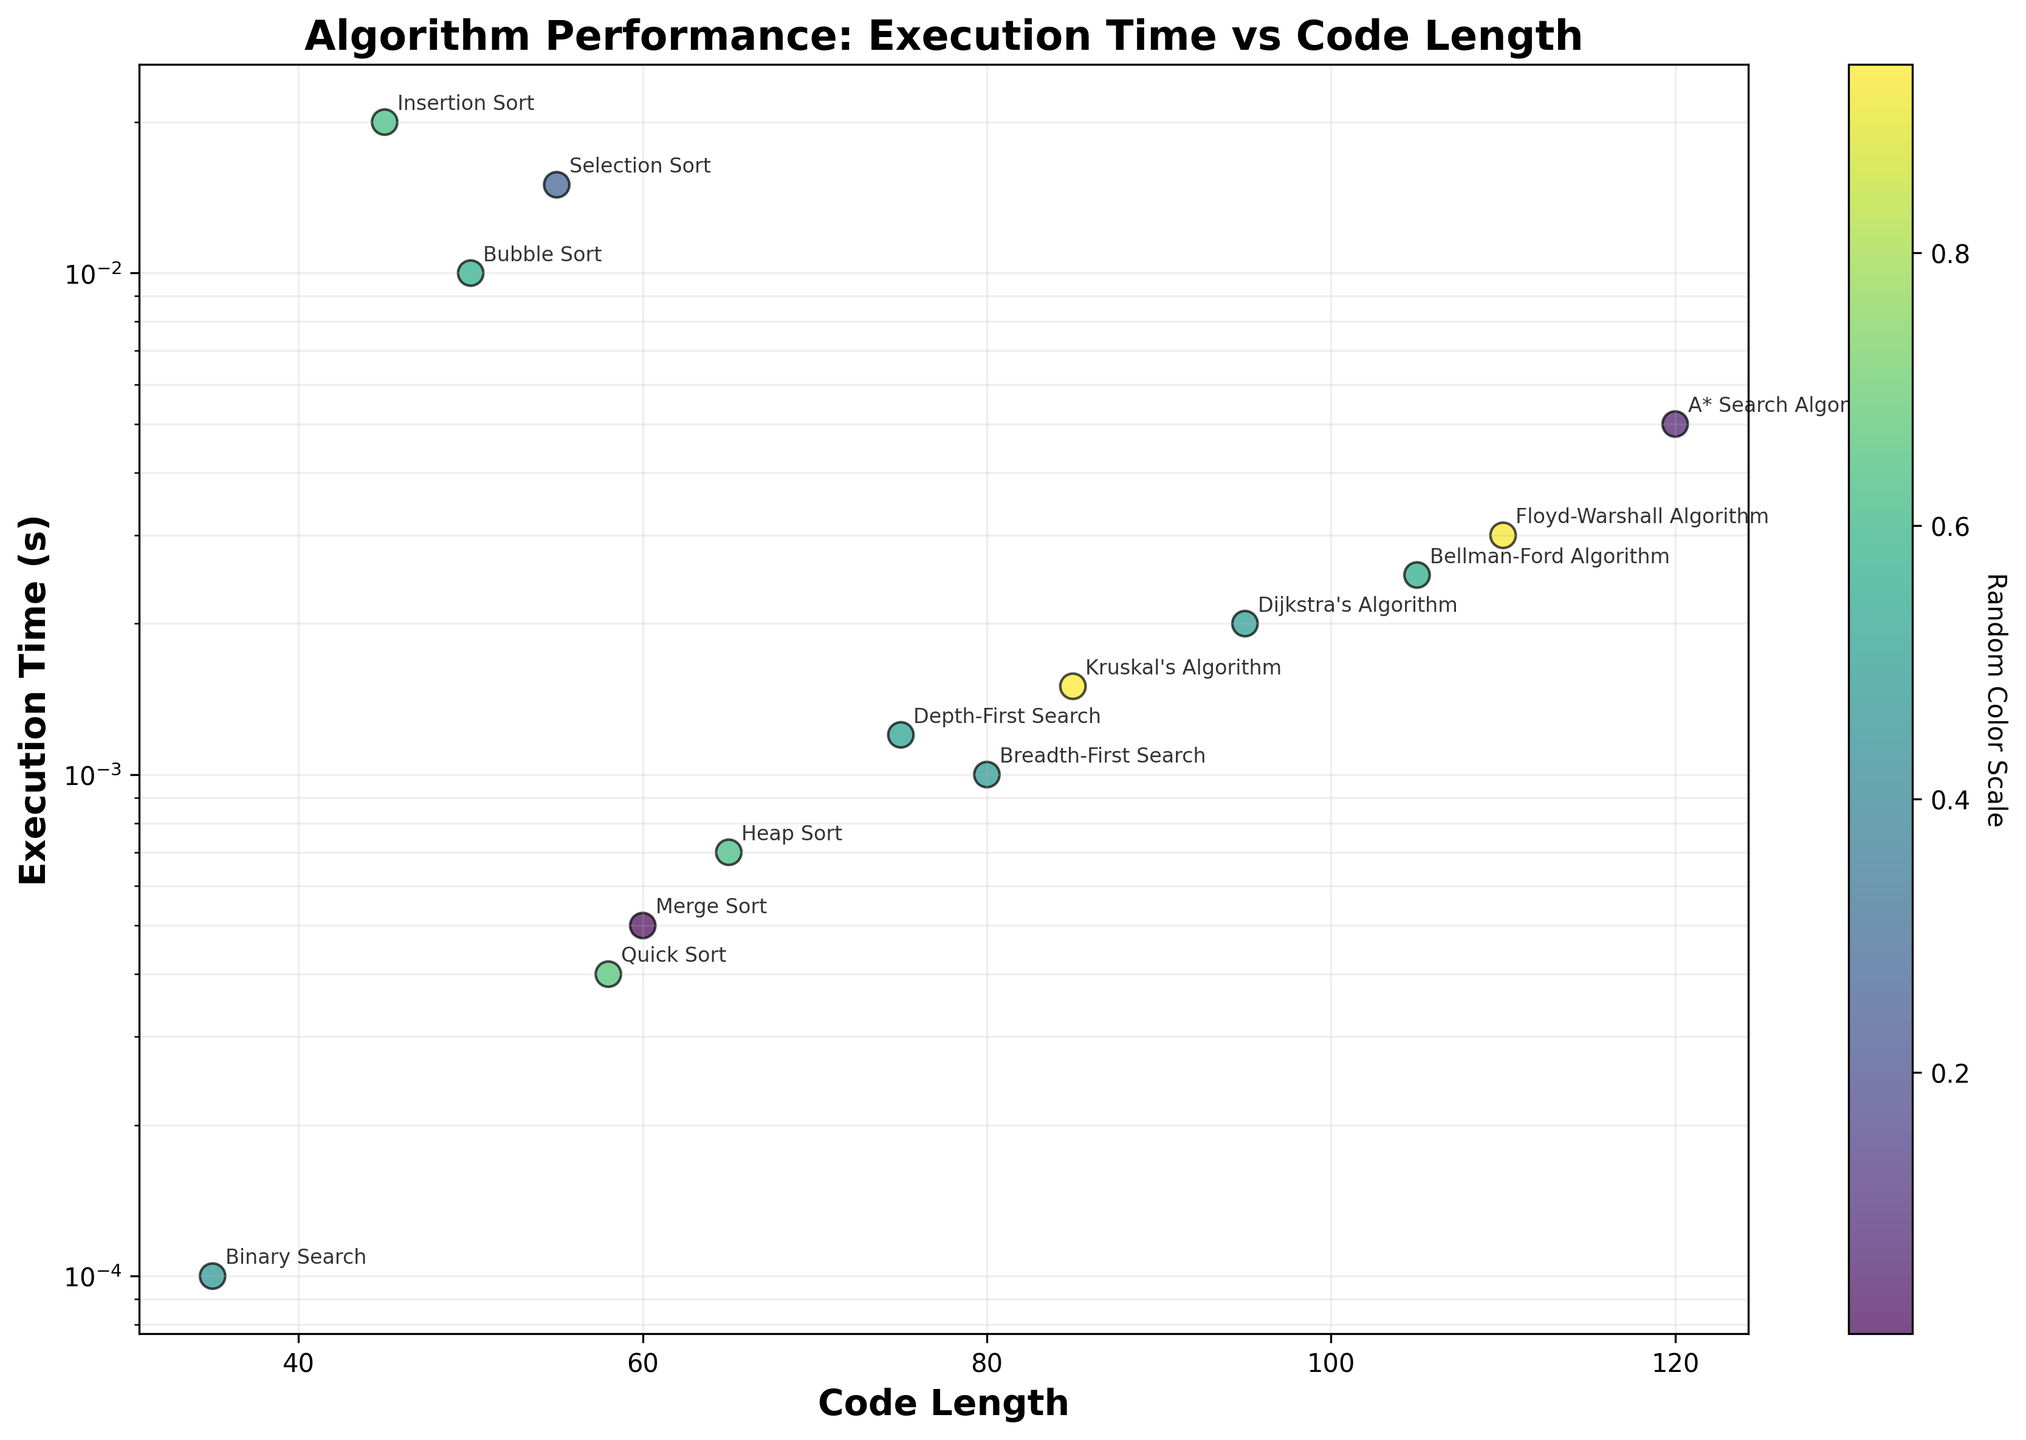What is the title of the scatter plot? The title is usually displayed prominently at the top of the figure. In this case, it reads "Algorithm Performance: Execution Time vs Code Length".
Answer: Algorithm Performance: Execution Time vs Code Length Which algorithm has the highest execution time? To identify the highest execution time, look for the point highest up on the y-axis. The A* Search Algorithm is at the highest position with an execution time of 0.005 seconds.
Answer: A* Search Algorithm Which algorithm has the smallest code length? To find the smallest code length, search for the point closest to the origin (0,0) on the x-axis. Binary Search is the closest with a code length of 35.
Answer: Binary Search How is the execution time distributed compared to the code length? Execution time values are distributed on a logarithmic scale while code lengths are displayed on a linear scale. This allows a spread-out visualization of execution times regardless of their wide range.
Answer: Logarithmic for execution time, linear for code length What is the execution time of Merge Sort? Locate the Merge Sort label and its corresponding point on the plot. Its y-axis position represents its execution time, which is at 0.0005 seconds.
Answer: 0.0005 seconds Comparing Quick Sort and Insertion Sort, which has a longer code length and execution time? Quick Sort has a code length of 58 and an execution time of 0.0004 seconds, while Insertion Sort has a code length of 45 and an execution time of 0.02 seconds. Quick Sort has a longer code length but shorter execution time.
Answer: Quick Sort has a longer code length, Insertion Sort has a longer execution time Which algorithm is closer in execution time to Dijkstra's Algorithm? We need to compare nearby execution times to Dijkstra's Algorithm (0.002 seconds). Breadth-First Search and Depth-First Search are nearby, at 0.001 and 0.0012 seconds respectively. Depth-First Search is closest at 0.0012 seconds.
Answer: Depth-First Search Which algorithms have execution times below 0.001 seconds, and what are their code lengths? Identify the points below the 0.001-second mark on the y-axis. These are Binary Search (35), Merge Sort (60), and Quick Sort (58).
Answer: Binary Search: 35, Merge Sort: 60, Quick Sort: 58 If we choose algorithms with code lengths above 100, what are their execution times? Look for points above the 100 mark on the x-axis. These include A* Search Algorithm (0.005 seconds), Bellman-Ford Algorithm (0.0025 seconds), and Floyd-Warshall Algorithm (0.003 seconds).
Answer: A* Search Algorithm: 0.005 seconds, Bellman-Ford Algorithm: 0.0025 seconds, Floyd-Warshall Algorithm: 0.003 seconds How many algorithms have execution times between 0.001 and 0.01 seconds? Count the points falling between the 0.001 and 0.01-second marks on the y-axis. These algorithms are Bubble Sort, Dijkstra's Algorithm, Kruskal's Algorithm, Floyd-Warshall Algorithm, Bellman-Ford Algorithm, Breadth-First Search, Depth-First Search, and A* Search Algorithm.
Answer: 8 algorithms 